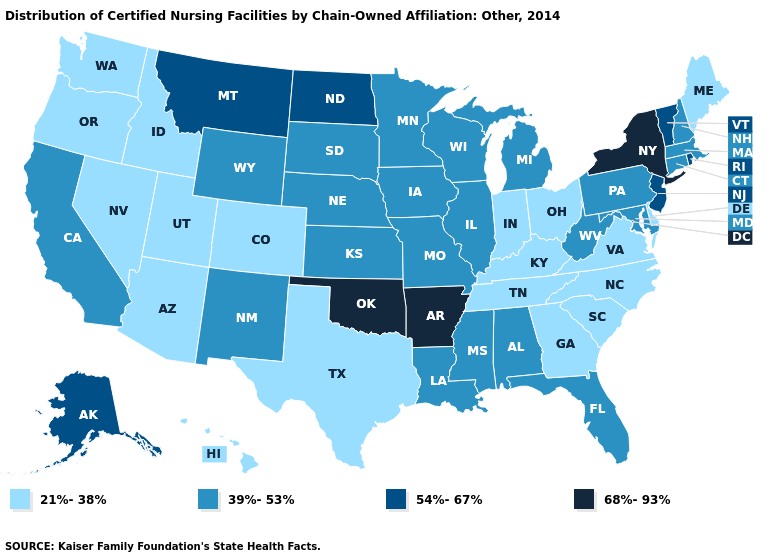Name the states that have a value in the range 68%-93%?
Quick response, please. Arkansas, New York, Oklahoma. What is the value of Maine?
Quick response, please. 21%-38%. Does Georgia have the highest value in the USA?
Write a very short answer. No. What is the value of Utah?
Write a very short answer. 21%-38%. Among the states that border Texas , which have the highest value?
Quick response, please. Arkansas, Oklahoma. What is the lowest value in the USA?
Keep it brief. 21%-38%. Does Massachusetts have a lower value than Wisconsin?
Be succinct. No. What is the value of New York?
Answer briefly. 68%-93%. Does New York have the highest value in the USA?
Give a very brief answer. Yes. Does New Jersey have the highest value in the Northeast?
Short answer required. No. What is the value of Georgia?
Be succinct. 21%-38%. What is the value of Washington?
Answer briefly. 21%-38%. What is the lowest value in the South?
Give a very brief answer. 21%-38%. How many symbols are there in the legend?
Quick response, please. 4. Does the first symbol in the legend represent the smallest category?
Give a very brief answer. Yes. 